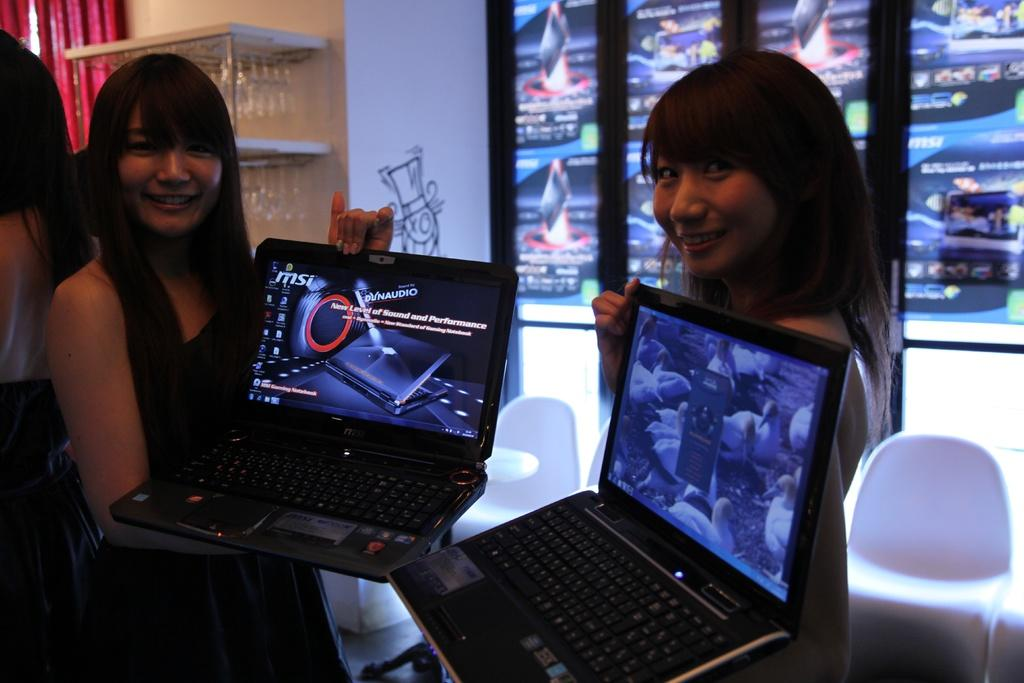How many women are present in the image? There are two women in the image. What are the women holding in the image? The women are holding laptops. Can you describe the background of the image? There is a chair, a screen, a wall, and a curtain in the background of the image. What type of cracker is being used to rate the women's performance in the image? There is no cracker present in the image, nor is there any indication of performance being rated. 